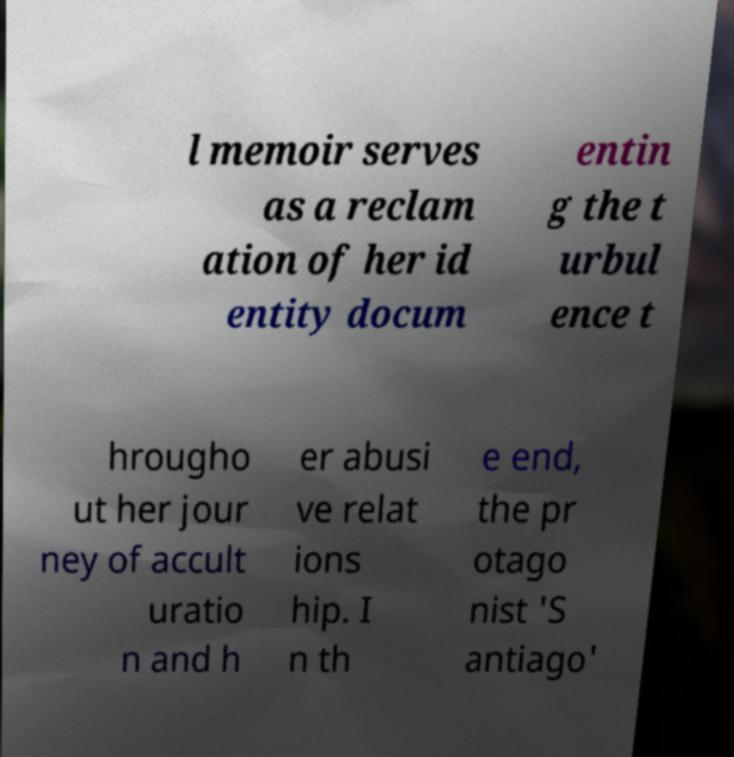Could you extract and type out the text from this image? l memoir serves as a reclam ation of her id entity docum entin g the t urbul ence t hrougho ut her jour ney of accult uratio n and h er abusi ve relat ions hip. I n th e end, the pr otago nist 'S antiago' 